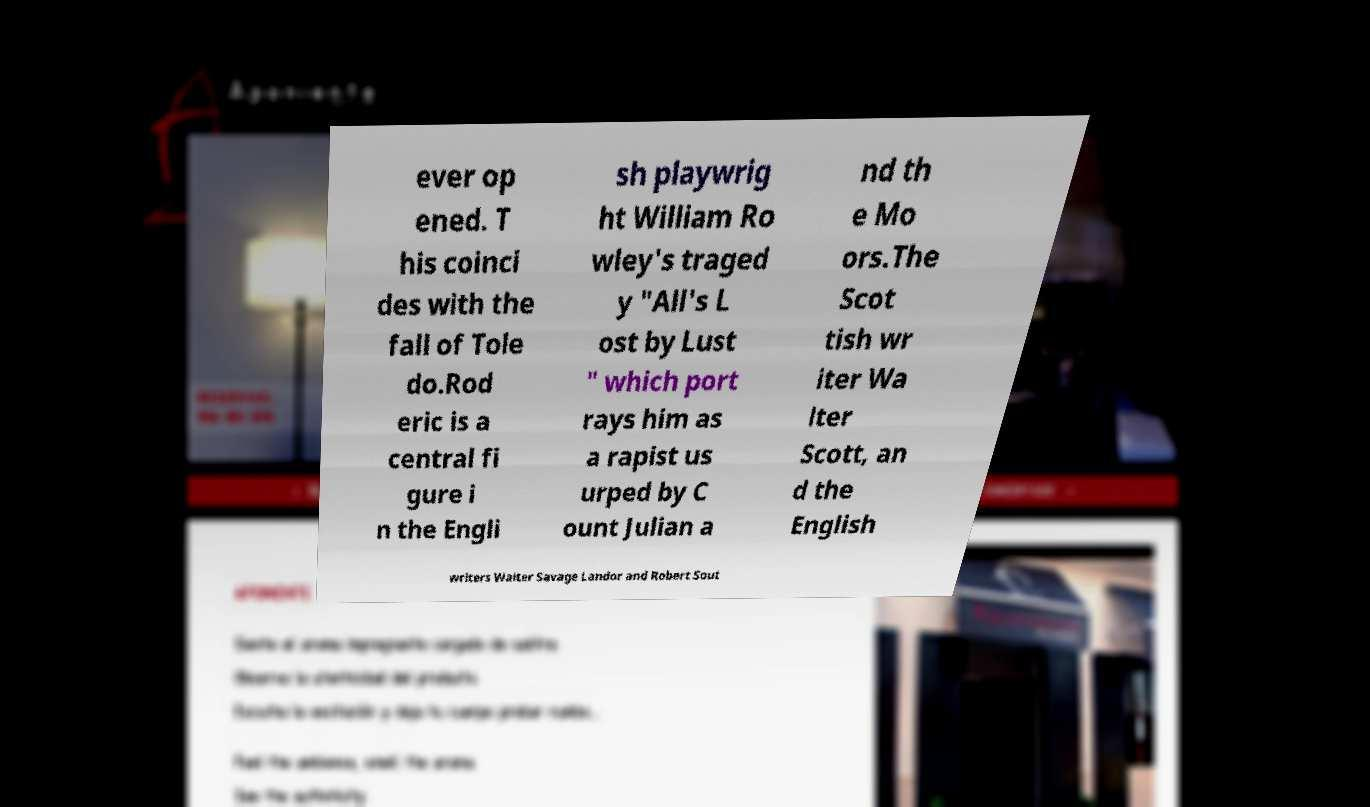Please identify and transcribe the text found in this image. ever op ened. T his coinci des with the fall of Tole do.Rod eric is a central fi gure i n the Engli sh playwrig ht William Ro wley's traged y "All's L ost by Lust " which port rays him as a rapist us urped by C ount Julian a nd th e Mo ors.The Scot tish wr iter Wa lter Scott, an d the English writers Walter Savage Landor and Robert Sout 